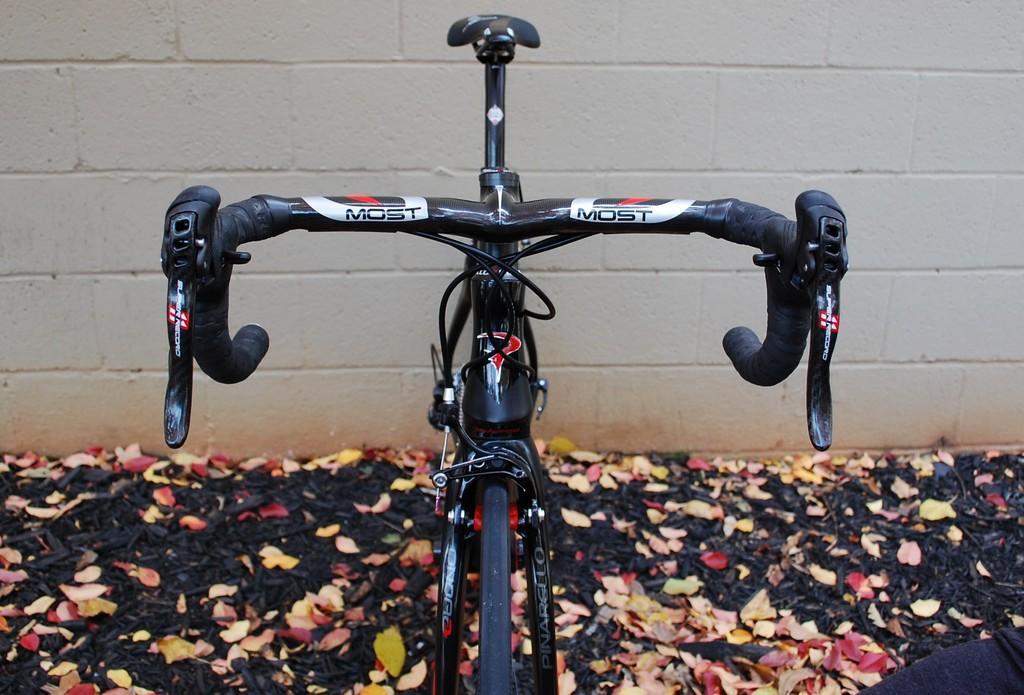In one or two sentences, can you explain what this image depicts? In this image, we can see bicycle with stickers. At the bottom of the image, we can see leaves. Background there is a wall. 